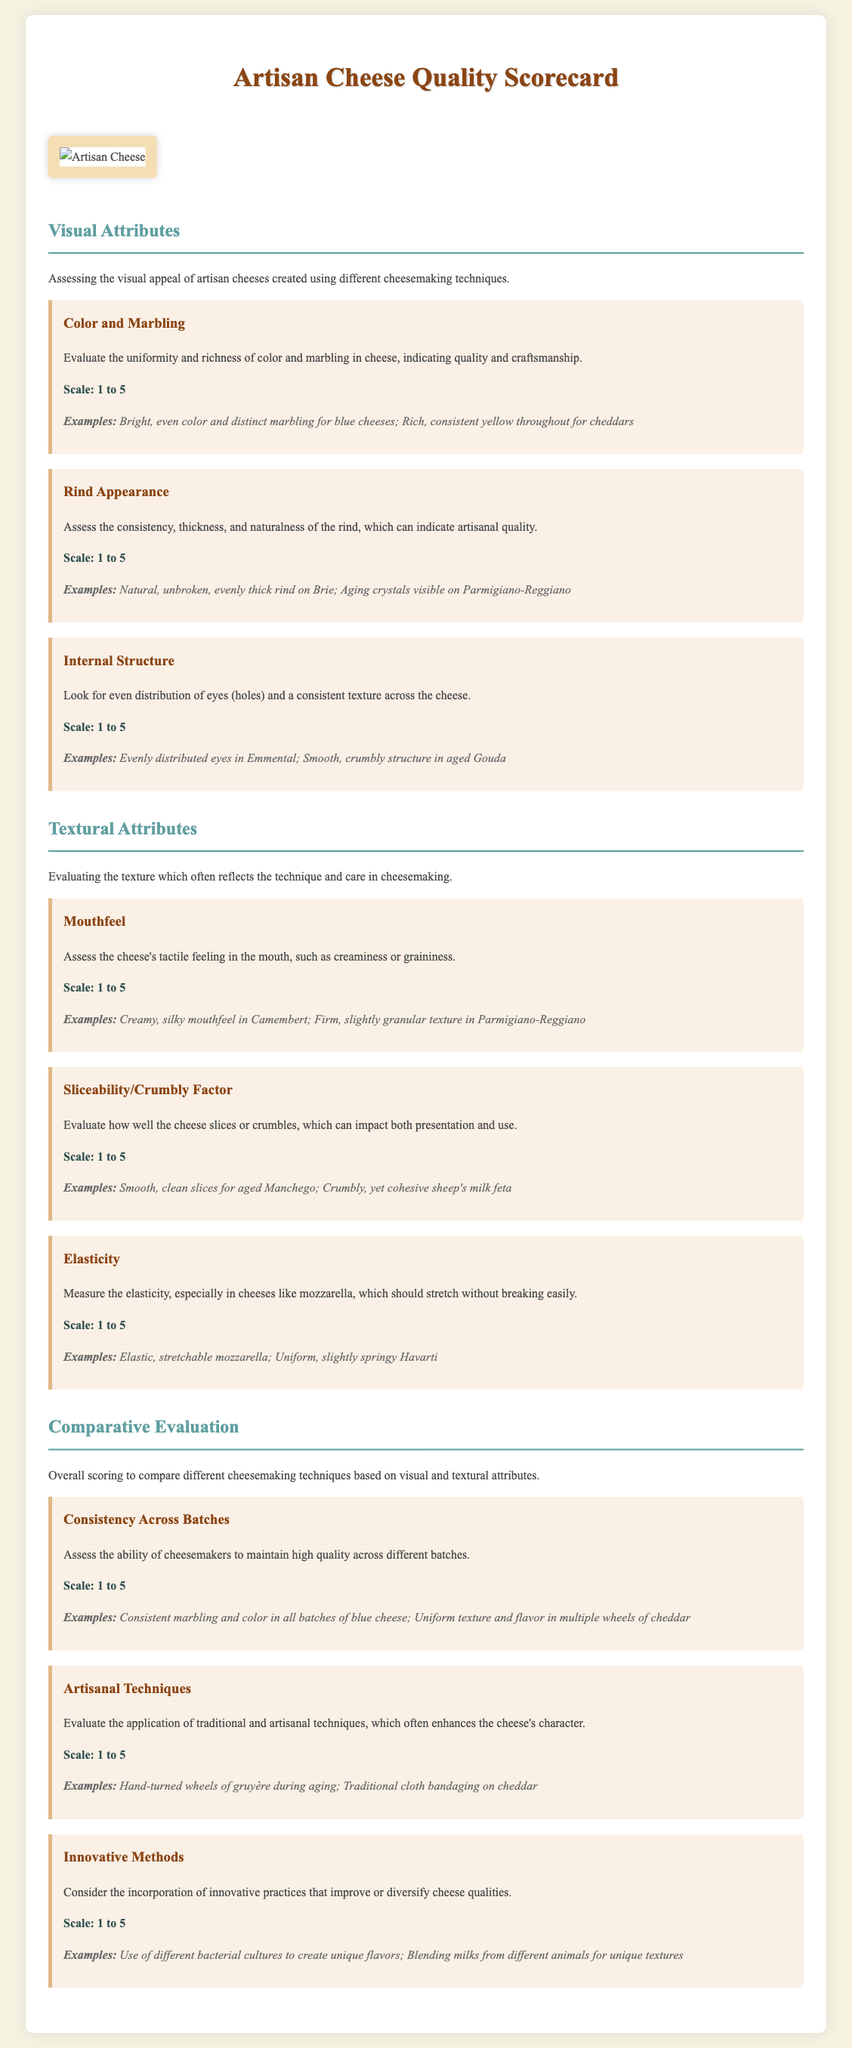What is the title of the document? The title of the document is stated in the header section of the scorecard.
Answer: Artisan Cheese Quality Scorecard What is the scale used for evaluating visual attributes? The scale specified for evaluating visual attributes is mentioned under each criterion related to visual assessment.
Answer: 1 to 5 Which cheese has a creamy, silky mouthfeel? The document provides examples of various cheeses and their mouthfeel characteristics.
Answer: Camembert What aspect does "Rind Appearance" evaluate? The section gives a specific detail about what "Rind Appearance" assesses in cheese quality.
Answer: Consistency, thickness, and naturalness What scoring criteria reflects the ability of cheesemakers to maintain quality? The criteria focuses on comparing quality consistency across batches of cheese.
Answer: Consistency Across Batches Which artisan technique involves hand-turned wheels during aging? The document provides an example related to artisanal techniques and their elaboration.
Answer: Gruyère How many criteria are listed under the "Textural Attributes" section? The document outlines how many criteria are included specifically in the textural attributes part.
Answer: Three What is evaluated under the "Innovative Methods" criterion? This section discusses specific practices that improve or diversify cheese qualities.
Answer: Incorporation of innovative practices What is assessed in the "Color and Marbling" criterion? The explanation in the document describes what to look for regarding color and marbling in cheese.
Answer: Uniformity and richness of color and marbling 